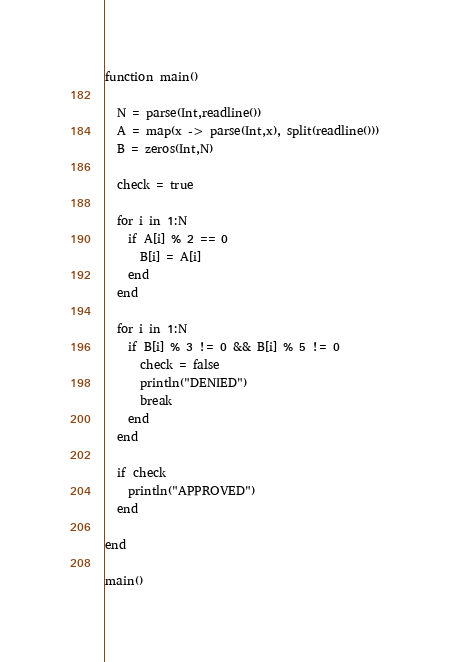Convert code to text. <code><loc_0><loc_0><loc_500><loc_500><_Julia_>function main()
  
  N = parse(Int,readline())
  A = map(x -> parse(Int,x), split(readline()))
  B = zeros(Int,N)
  
  check = true
  
  for i in 1:N
    if A[i] % 2 == 0
      B[i] = A[i]
    end
  end
  
  for i in 1:N
    if B[i] % 3 != 0 && B[i] % 5 != 0
      check = false
      println("DENIED")
      break
    end
  end
  
  if check
    println("APPROVED")
  end
  
end

main()</code> 